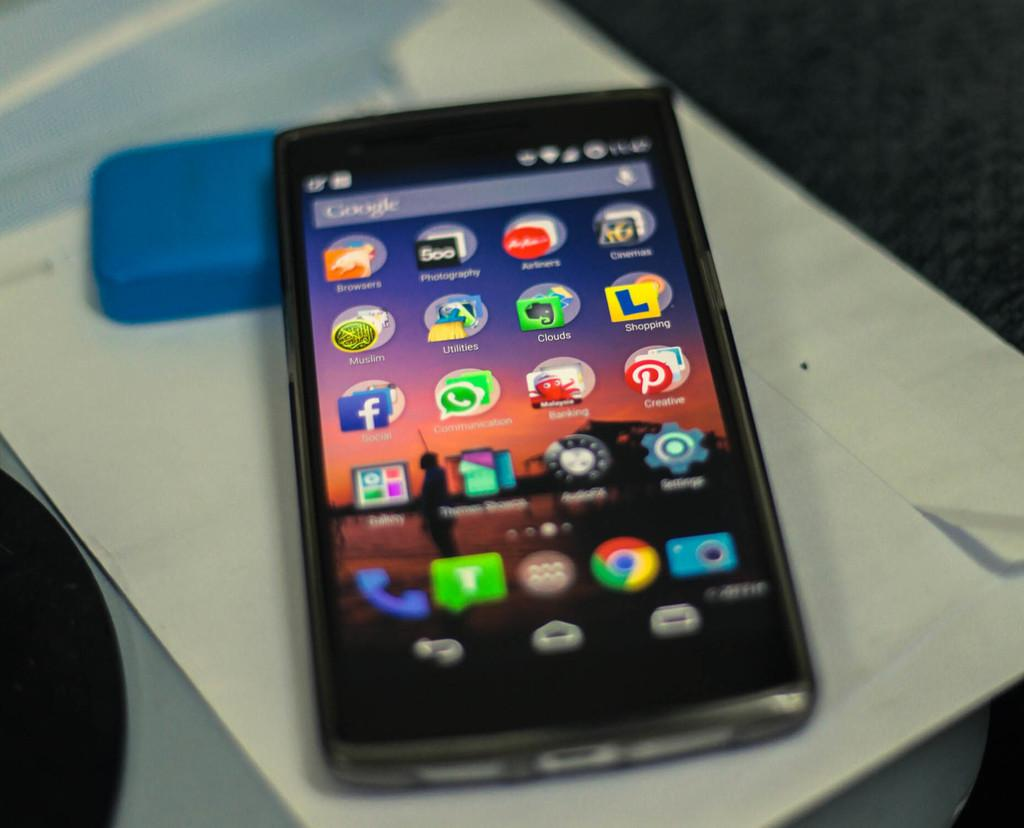Provide a one-sentence caption for the provided image. A cell phone home page shows an f icon for facebook on the left. 